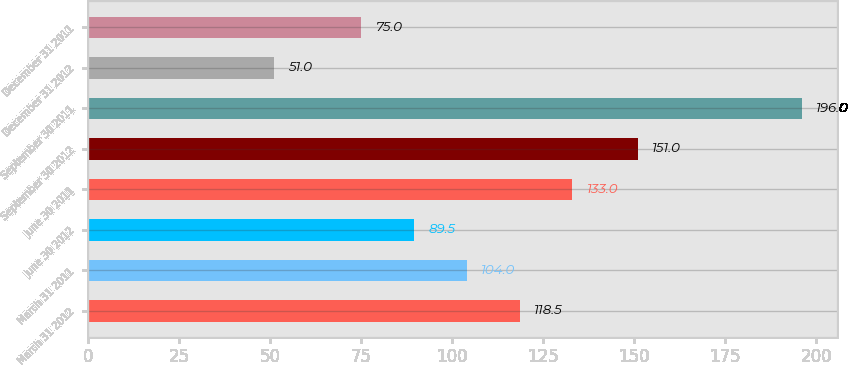Convert chart to OTSL. <chart><loc_0><loc_0><loc_500><loc_500><bar_chart><fcel>March 31 2012<fcel>March 31 2011<fcel>June 30 2012<fcel>June 30 2011<fcel>September 30 2012<fcel>September 30 2011<fcel>December 31 2012<fcel>December 31 2011<nl><fcel>118.5<fcel>104<fcel>89.5<fcel>133<fcel>151<fcel>196<fcel>51<fcel>75<nl></chart> 